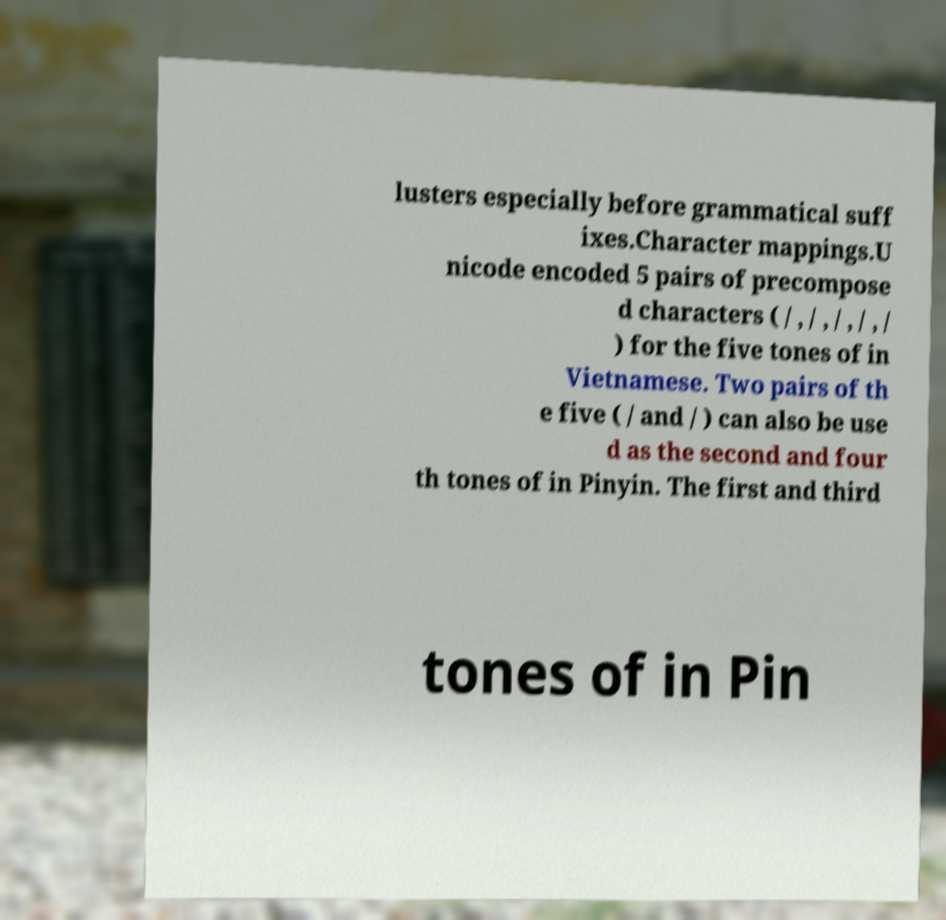Please read and relay the text visible in this image. What does it say? lusters especially before grammatical suff ixes.Character mappings.U nicode encoded 5 pairs of precompose d characters ( / , / , / , / , / ) for the five tones of in Vietnamese. Two pairs of th e five ( / and / ) can also be use d as the second and four th tones of in Pinyin. The first and third tones of in Pin 